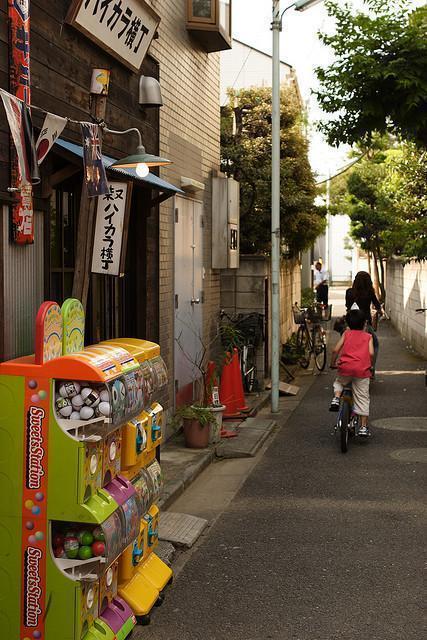What are the colorful machines called?
Choose the correct response and explain in the format: 'Answer: answer
Rationale: rationale.'
Options: Garbage bins, mailboxes, vending machines, storage lockers. Answer: vending machines.
Rationale: You can get prizes from the machines. 